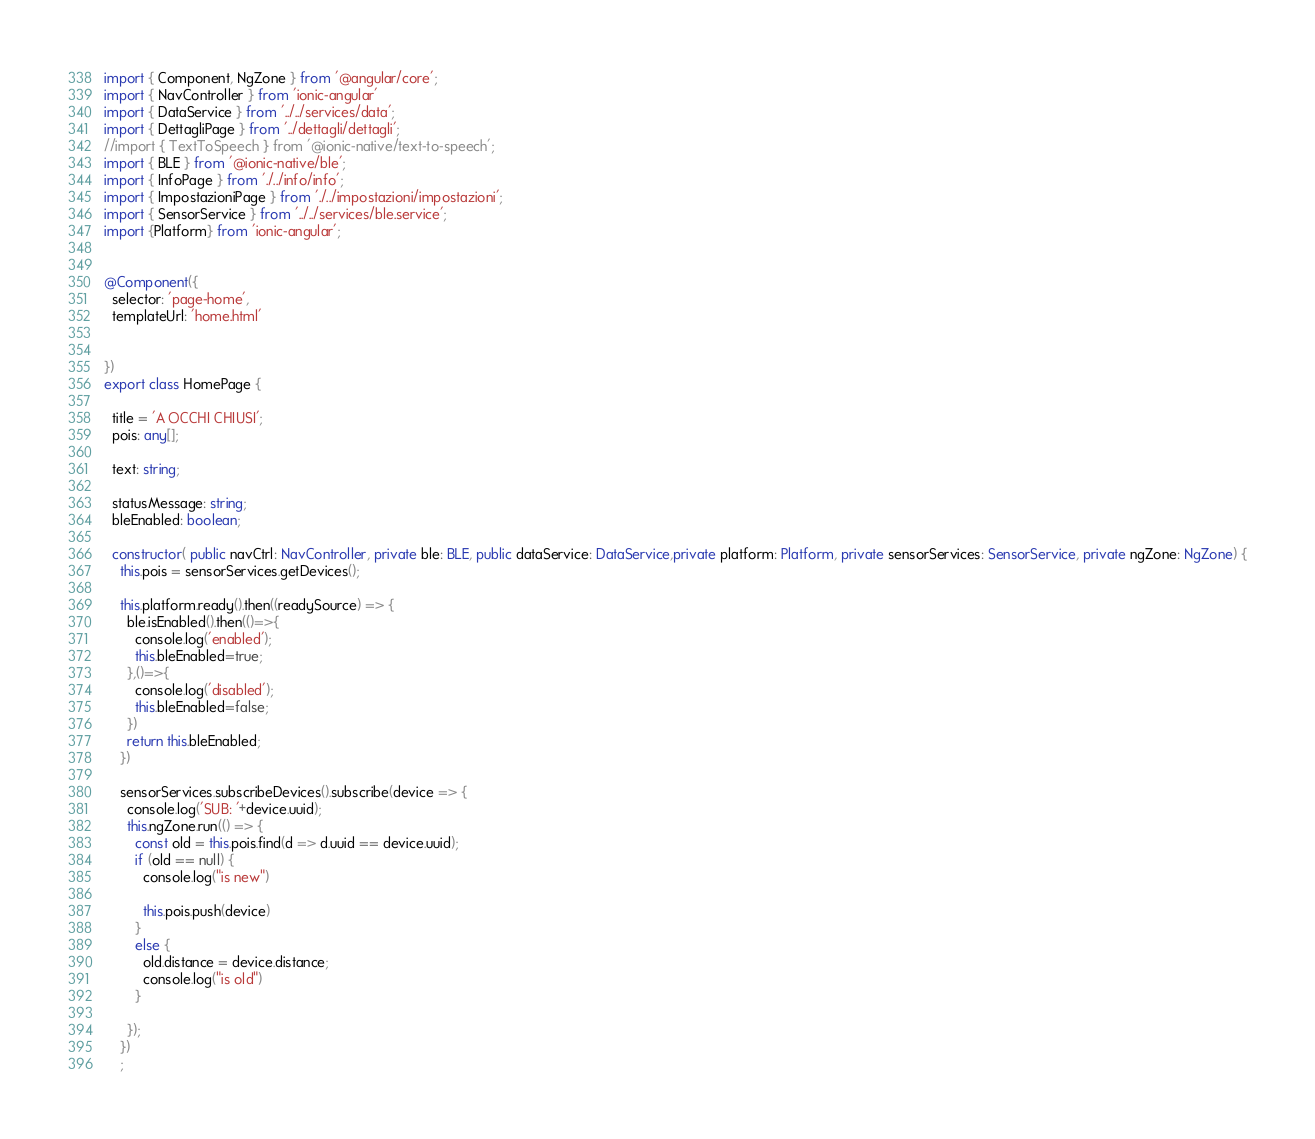<code> <loc_0><loc_0><loc_500><loc_500><_TypeScript_>
import { Component, NgZone } from '@angular/core';
import { NavController } from 'ionic-angular'
import { DataService } from '../../services/data';
import { DettagliPage } from '../dettagli/dettagli';
//import { TextToSpeech } from '@ionic-native/text-to-speech';
import { BLE } from '@ionic-native/ble';
import { InfoPage } from './../info/info';
import { ImpostazioniPage } from './../impostazioni/impostazioni';
import { SensorService } from '../../services/ble.service';
import {Platform} from 'ionic-angular';


@Component({
  selector: 'page-home',
  templateUrl: 'home.html'


})
export class HomePage {
  
  title = 'A OCCHI CHIUSI';
  pois: any[];

  text: string;

  statusMessage: string;
  bleEnabled: boolean;

  constructor( public navCtrl: NavController, private ble: BLE, public dataService: DataService,private platform: Platform, private sensorServices: SensorService, private ngZone: NgZone) {
    this.pois = sensorServices.getDevices();

    this.platform.ready().then((readySource) => {
      ble.isEnabled().then(()=>{
        console.log('enabled');
        this.bleEnabled=true;
      },()=>{
        console.log('disabled');
        this.bleEnabled=false;
      })
      return this.bleEnabled;
    })
    
    sensorServices.subscribeDevices().subscribe(device => {
      console.log('SUB: '+device.uuid);
      this.ngZone.run(() => {
        const old = this.pois.find(d => d.uuid == device.uuid);
        if (old == null) {
          console.log("is new")

          this.pois.push(device)
        }
        else {
          old.distance = device.distance;
          console.log("is old")
        }
  
      });
    })
    ;
</code> 